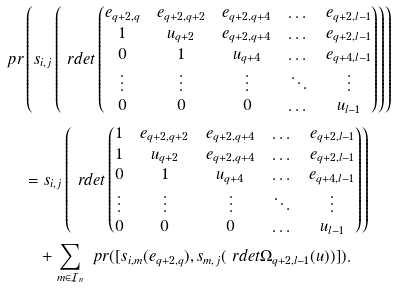Convert formula to latex. <formula><loc_0><loc_0><loc_500><loc_500>\ p r & \left ( s _ { i , j } \left ( \ r d e t \begin{pmatrix} e _ { q + 2 , q } & e _ { q + 2 , q + 2 } & e _ { q + 2 , q + 4 } & \dots & e _ { q + 2 , l - 1 } \\ 1 & u _ { q + 2 } & e _ { q + 2 , q + 4 } & \dots & e _ { q + 2 , l - 1 } \\ 0 & 1 & u _ { q + 4 } & \dots & e _ { q + 4 , l - 1 } \\ \vdots & \vdots & \vdots & \ddots & \vdots \\ 0 & 0 & 0 & \dots & u _ { l - 1 } \end{pmatrix} \right ) \right ) \\ & = s _ { i , j } \left ( \ r d e t \begin{pmatrix} 1 & e _ { q + 2 , q + 2 } & e _ { q + 2 , q + 4 } & \dots & e _ { q + 2 , l - 1 } \\ 1 & u _ { q + 2 } & e _ { q + 2 , q + 4 } & \dots & e _ { q + 2 , l - 1 } \\ 0 & 1 & u _ { q + 4 } & \dots & e _ { q + 4 , l - 1 } \\ \vdots & \vdots & \vdots & \ddots & \vdots \\ 0 & 0 & 0 & \dots & u _ { l - 1 } \end{pmatrix} \right ) \\ & \quad + \sum _ { m \in \mathcal { I } _ { n } } \ p r ( [ s _ { i , m } ( e _ { q + 2 , q } ) , s _ { m , j } ( \ r d e t \Omega _ { q + 2 , l - 1 } ( u ) ) ] ) .</formula> 